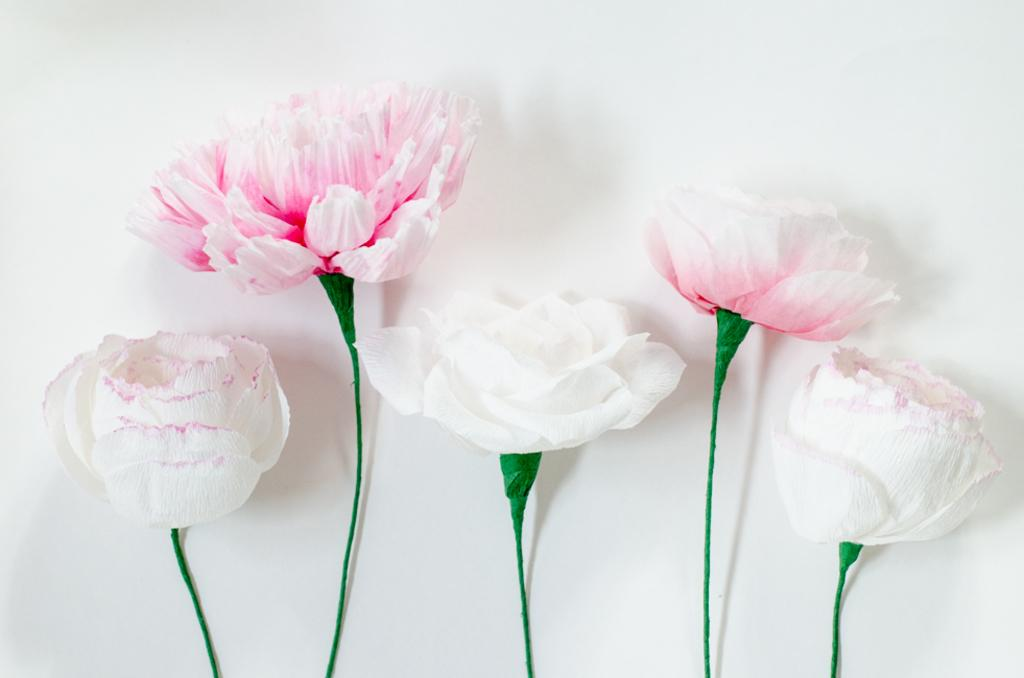What type of plants are in the image? There are flowers in the image. What colors are the flowers? The flowers are in white and pink colors. What is the color of the object below the flowers? There is a green color object below the flowers. What type of milk is being poured into the selection of flowers in the image? There is no milk or pouring action depicted in the image; it features flowers in white and pink colors with a green object below them. 